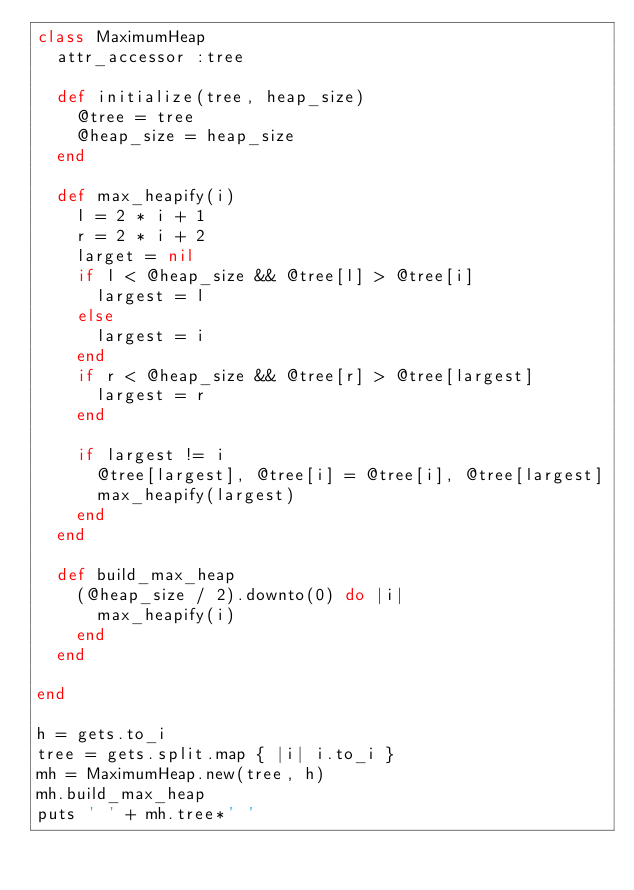Convert code to text. <code><loc_0><loc_0><loc_500><loc_500><_Ruby_>class MaximumHeap
  attr_accessor :tree

  def initialize(tree, heap_size)
    @tree = tree
    @heap_size = heap_size
  end

  def max_heapify(i)
    l = 2 * i + 1
    r = 2 * i + 2
    larget = nil
    if l < @heap_size && @tree[l] > @tree[i]
      largest = l
    else
      largest = i
    end
    if r < @heap_size && @tree[r] > @tree[largest]
      largest = r
    end

    if largest != i
      @tree[largest], @tree[i] = @tree[i], @tree[largest]
      max_heapify(largest)
    end
  end

  def build_max_heap
    (@heap_size / 2).downto(0) do |i|
      max_heapify(i)
    end
  end

end

h = gets.to_i
tree = gets.split.map { |i| i.to_i }
mh = MaximumHeap.new(tree, h)
mh.build_max_heap
puts ' ' + mh.tree*' '</code> 